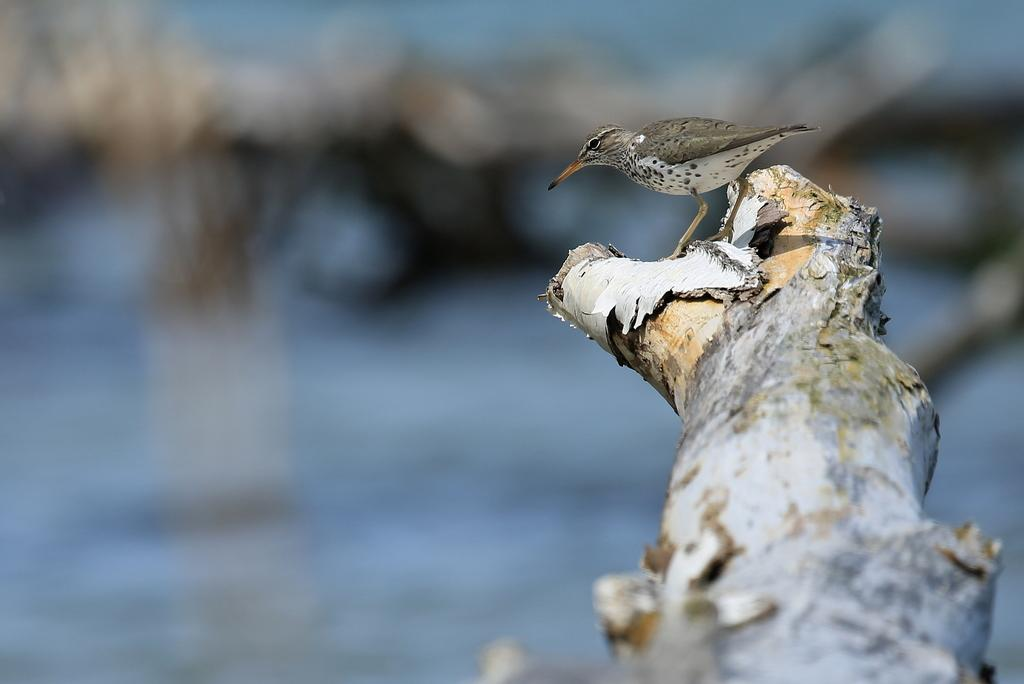What type of animal is in the image? There is a bird in the image. What is the bird standing on? The bird is standing on wood. How would you describe the background of the image? The background of the image is blurry. What health advice is the bird giving in the image? There is no indication in the image that the bird is giving health advice, as birds do not communicate in this manner. 